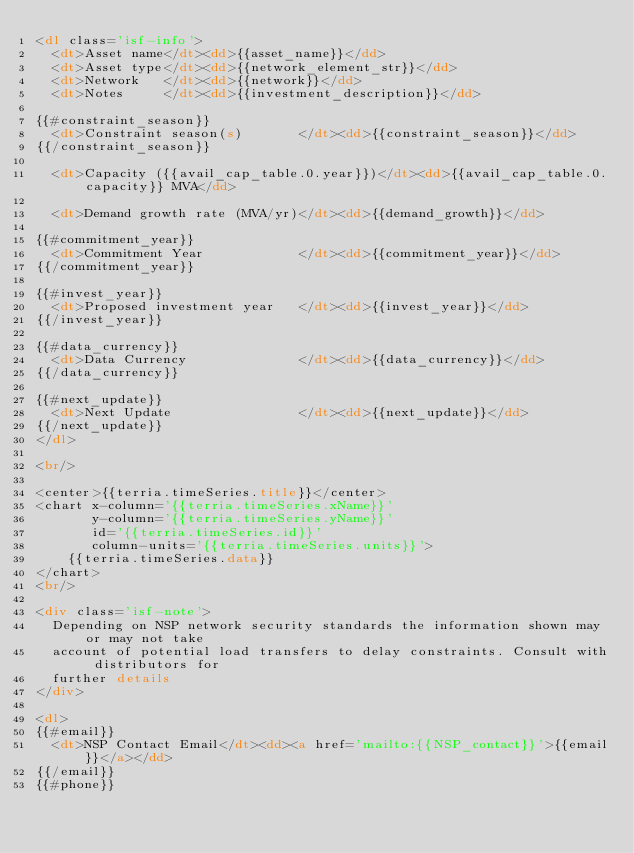<code> <loc_0><loc_0><loc_500><loc_500><_HTML_><dl class='isf-info'>
  <dt>Asset name</dt><dd>{{asset_name}}</dd>
  <dt>Asset type</dt><dd>{{network_element_str}}</dd>
  <dt>Network   </dt><dd>{{network}}</dd>
  <dt>Notes     </dt><dd>{{investment_description}}</dd>

{{#constraint_season}}
  <dt>Constraint season(s)       </dt><dd>{{constraint_season}}</dd>
{{/constraint_season}}

  <dt>Capacity ({{avail_cap_table.0.year}})</dt><dd>{{avail_cap_table.0.capacity}} MVA</dd>

  <dt>Demand growth rate (MVA/yr)</dt><dd>{{demand_growth}}</dd>

{{#commitment_year}}
  <dt>Commitment Year            </dt><dd>{{commitment_year}}</dd>
{{/commitment_year}}

{{#invest_year}}
  <dt>Proposed investment year   </dt><dd>{{invest_year}}</dd>
{{/invest_year}}

{{#data_currency}}
  <dt>Data Currency              </dt><dd>{{data_currency}}</dd>
{{/data_currency}}

{{#next_update}}
  <dt>Next Update                </dt><dd>{{next_update}}</dd>
{{/next_update}}
</dl>

<br/>

<center>{{terria.timeSeries.title}}</center>
<chart x-column='{{terria.timeSeries.xName}}'
       y-column='{{terria.timeSeries.yName}}'
       id='{{terria.timeSeries.id}}'
       column-units='{{terria.timeSeries.units}}'>
    {{terria.timeSeries.data}}
</chart>
<br/>

<div class='isf-note'>
  Depending on NSP network security standards the information shown may or may not take
  account of potential load transfers to delay constraints. Consult with distributors for
  further details
</div>

<dl>
{{#email}}
  <dt>NSP Contact Email</dt><dd><a href='mailto:{{NSP_contact}}'>{{email}}</a></dd>
{{/email}}
{{#phone}}</code> 